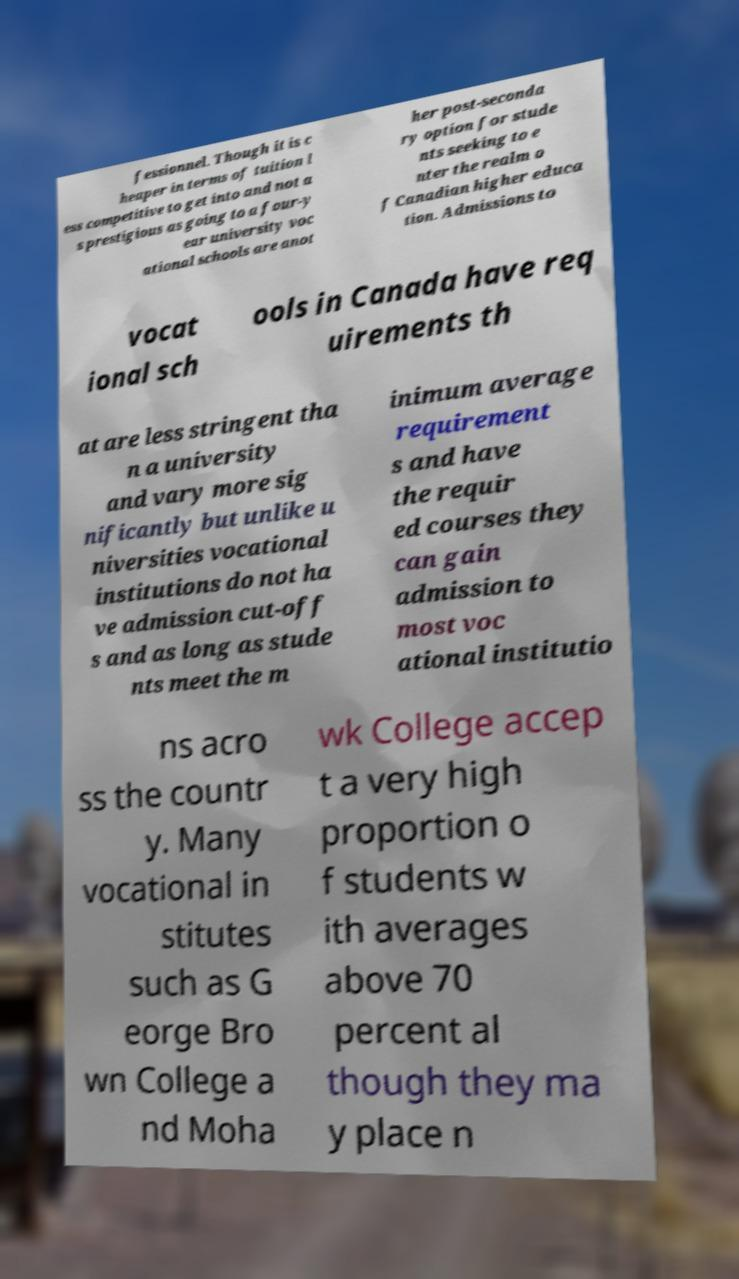Please read and relay the text visible in this image. What does it say? fessionnel. Though it is c heaper in terms of tuition l ess competitive to get into and not a s prestigious as going to a four-y ear university voc ational schools are anot her post-seconda ry option for stude nts seeking to e nter the realm o f Canadian higher educa tion. Admissions to vocat ional sch ools in Canada have req uirements th at are less stringent tha n a university and vary more sig nificantly but unlike u niversities vocational institutions do not ha ve admission cut-off s and as long as stude nts meet the m inimum average requirement s and have the requir ed courses they can gain admission to most voc ational institutio ns acro ss the countr y. Many vocational in stitutes such as G eorge Bro wn College a nd Moha wk College accep t a very high proportion o f students w ith averages above 70 percent al though they ma y place n 